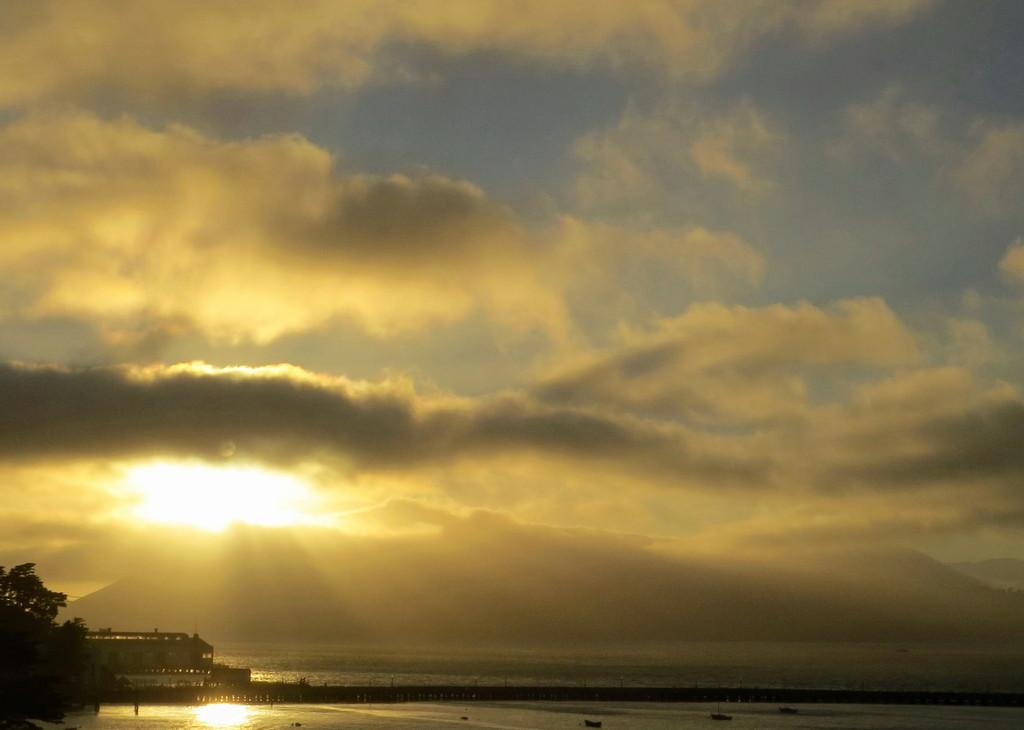What type of vegetation can be seen in the image? There are trees in the image. What part of the natural environment is visible in the image? The sky is visible in the background of the image. What type of wax can be seen dripping from the trees in the image? There is no wax present in the image; it only features trees and the sky. 